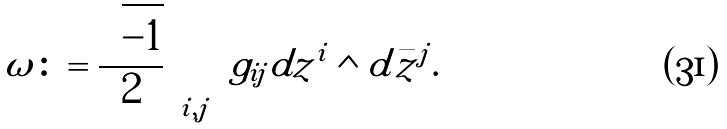<formula> <loc_0><loc_0><loc_500><loc_500>\omega \colon = \frac { \sqrt { - 1 } } { 2 } \sum _ { i , j } g _ { i j } d z ^ { i } \wedge d \bar { z } ^ { j } .</formula> 